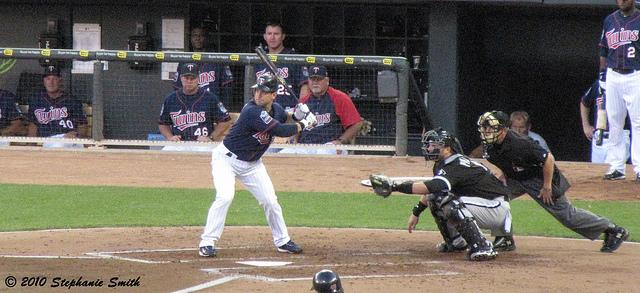What state is the batter's team located in? Please explain your reasoning. minnesota. The twins are a baseball team that play in minnesota. 